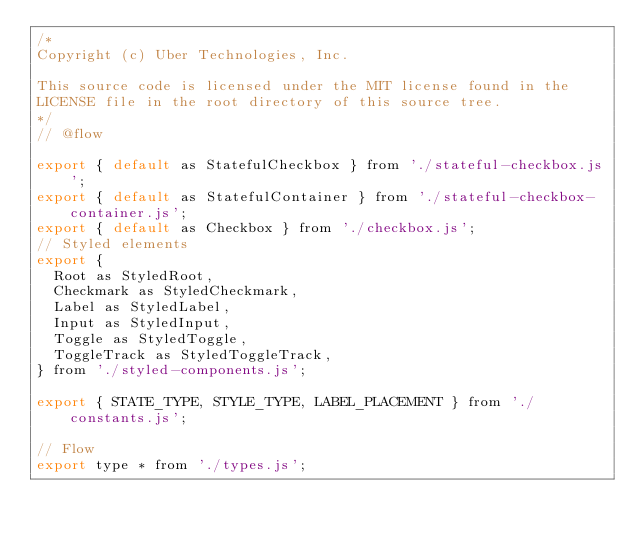<code> <loc_0><loc_0><loc_500><loc_500><_JavaScript_>/*
Copyright (c) Uber Technologies, Inc.

This source code is licensed under the MIT license found in the
LICENSE file in the root directory of this source tree.
*/
// @flow

export { default as StatefulCheckbox } from './stateful-checkbox.js';
export { default as StatefulContainer } from './stateful-checkbox-container.js';
export { default as Checkbox } from './checkbox.js';
// Styled elements
export {
  Root as StyledRoot,
  Checkmark as StyledCheckmark,
  Label as StyledLabel,
  Input as StyledInput,
  Toggle as StyledToggle,
  ToggleTrack as StyledToggleTrack,
} from './styled-components.js';

export { STATE_TYPE, STYLE_TYPE, LABEL_PLACEMENT } from './constants.js';

// Flow
export type * from './types.js';
</code> 